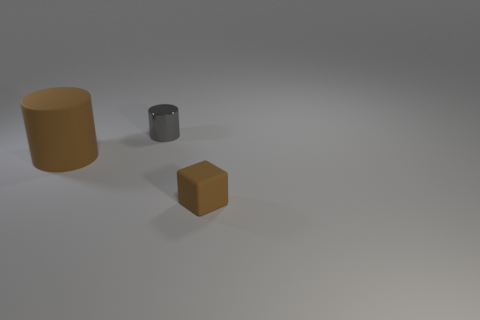Is there anything else that is the same size as the brown cylinder?
Provide a succinct answer. No. Do the shiny thing and the rubber object on the left side of the small metal object have the same size?
Make the answer very short. No. Are there any other things that have the same shape as the small brown thing?
Your answer should be very brief. No. What is the size of the rubber block that is the same color as the large matte cylinder?
Offer a terse response. Small. Is the brown thing behind the small brown rubber cube made of the same material as the gray cylinder?
Provide a succinct answer. No. Are there any small cylinders that have the same color as the big matte object?
Offer a very short reply. No. Is the shape of the rubber object left of the small gray metal cylinder the same as the thing that is behind the big cylinder?
Your answer should be compact. Yes. Are there any tiny brown blocks that have the same material as the big thing?
Provide a succinct answer. Yes. What number of yellow objects are either small cylinders or cylinders?
Provide a succinct answer. 0. There is a thing that is both on the left side of the brown matte cube and in front of the metallic cylinder; what size is it?
Provide a short and direct response. Large. 